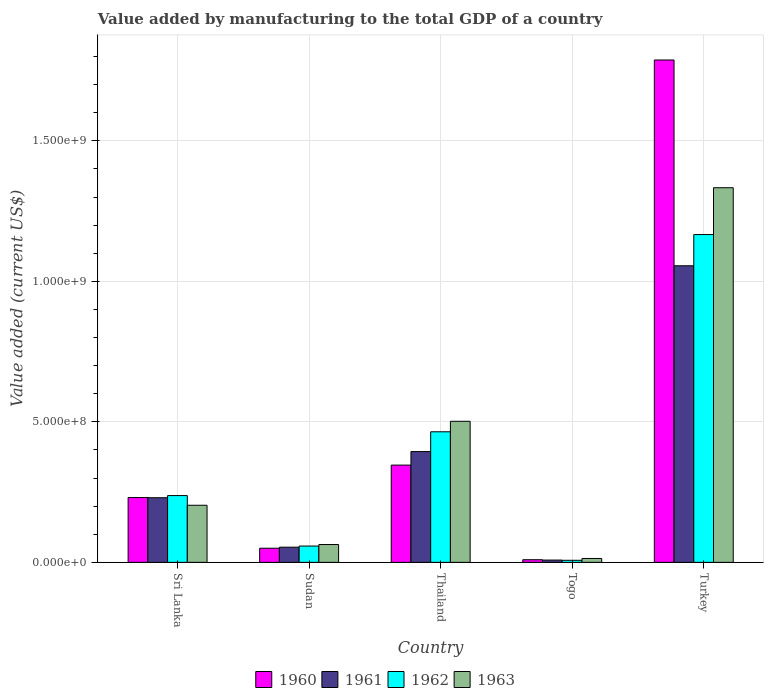How many different coloured bars are there?
Offer a very short reply. 4. How many bars are there on the 1st tick from the left?
Your answer should be compact. 4. How many bars are there on the 5th tick from the right?
Your answer should be compact. 4. What is the label of the 3rd group of bars from the left?
Your answer should be compact. Thailand. What is the value added by manufacturing to the total GDP in 1962 in Turkey?
Offer a terse response. 1.17e+09. Across all countries, what is the maximum value added by manufacturing to the total GDP in 1961?
Give a very brief answer. 1.06e+09. Across all countries, what is the minimum value added by manufacturing to the total GDP in 1961?
Keep it short and to the point. 8.15e+06. In which country was the value added by manufacturing to the total GDP in 1962 maximum?
Your response must be concise. Turkey. In which country was the value added by manufacturing to the total GDP in 1960 minimum?
Provide a short and direct response. Togo. What is the total value added by manufacturing to the total GDP in 1962 in the graph?
Offer a terse response. 1.93e+09. What is the difference between the value added by manufacturing to the total GDP in 1963 in Sri Lanka and that in Togo?
Make the answer very short. 1.89e+08. What is the difference between the value added by manufacturing to the total GDP in 1963 in Sudan and the value added by manufacturing to the total GDP in 1960 in Thailand?
Keep it short and to the point. -2.83e+08. What is the average value added by manufacturing to the total GDP in 1963 per country?
Give a very brief answer. 4.23e+08. What is the difference between the value added by manufacturing to the total GDP of/in 1962 and value added by manufacturing to the total GDP of/in 1963 in Togo?
Provide a short and direct response. -6.53e+06. In how many countries, is the value added by manufacturing to the total GDP in 1961 greater than 1500000000 US$?
Offer a terse response. 0. What is the ratio of the value added by manufacturing to the total GDP in 1961 in Togo to that in Turkey?
Give a very brief answer. 0.01. Is the value added by manufacturing to the total GDP in 1960 in Togo less than that in Turkey?
Make the answer very short. Yes. Is the difference between the value added by manufacturing to the total GDP in 1962 in Sudan and Thailand greater than the difference between the value added by manufacturing to the total GDP in 1963 in Sudan and Thailand?
Your answer should be compact. Yes. What is the difference between the highest and the second highest value added by manufacturing to the total GDP in 1960?
Make the answer very short. 1.56e+09. What is the difference between the highest and the lowest value added by manufacturing to the total GDP in 1961?
Provide a succinct answer. 1.05e+09. What does the 4th bar from the right in Thailand represents?
Your answer should be compact. 1960. How many bars are there?
Your answer should be compact. 20. Are all the bars in the graph horizontal?
Ensure brevity in your answer.  No. How many countries are there in the graph?
Make the answer very short. 5. What is the difference between two consecutive major ticks on the Y-axis?
Offer a terse response. 5.00e+08. Are the values on the major ticks of Y-axis written in scientific E-notation?
Offer a very short reply. Yes. Where does the legend appear in the graph?
Provide a short and direct response. Bottom center. How are the legend labels stacked?
Your response must be concise. Horizontal. What is the title of the graph?
Your answer should be compact. Value added by manufacturing to the total GDP of a country. Does "1996" appear as one of the legend labels in the graph?
Your answer should be very brief. No. What is the label or title of the Y-axis?
Ensure brevity in your answer.  Value added (current US$). What is the Value added (current US$) of 1960 in Sri Lanka?
Give a very brief answer. 2.31e+08. What is the Value added (current US$) in 1961 in Sri Lanka?
Your response must be concise. 2.30e+08. What is the Value added (current US$) in 1962 in Sri Lanka?
Give a very brief answer. 2.38e+08. What is the Value added (current US$) in 1963 in Sri Lanka?
Make the answer very short. 2.03e+08. What is the Value added (current US$) of 1960 in Sudan?
Give a very brief answer. 5.03e+07. What is the Value added (current US$) of 1961 in Sudan?
Provide a short and direct response. 5.40e+07. What is the Value added (current US$) in 1962 in Sudan?
Your response must be concise. 5.80e+07. What is the Value added (current US$) of 1963 in Sudan?
Make the answer very short. 6.35e+07. What is the Value added (current US$) in 1960 in Thailand?
Keep it short and to the point. 3.46e+08. What is the Value added (current US$) in 1961 in Thailand?
Provide a short and direct response. 3.94e+08. What is the Value added (current US$) of 1962 in Thailand?
Your response must be concise. 4.65e+08. What is the Value added (current US$) in 1963 in Thailand?
Offer a very short reply. 5.02e+08. What is the Value added (current US$) in 1960 in Togo?
Your answer should be compact. 9.38e+06. What is the Value added (current US$) in 1961 in Togo?
Your response must be concise. 8.15e+06. What is the Value added (current US$) in 1962 in Togo?
Provide a short and direct response. 7.35e+06. What is the Value added (current US$) in 1963 in Togo?
Provide a succinct answer. 1.39e+07. What is the Value added (current US$) of 1960 in Turkey?
Your answer should be very brief. 1.79e+09. What is the Value added (current US$) in 1961 in Turkey?
Keep it short and to the point. 1.06e+09. What is the Value added (current US$) of 1962 in Turkey?
Offer a very short reply. 1.17e+09. What is the Value added (current US$) of 1963 in Turkey?
Provide a short and direct response. 1.33e+09. Across all countries, what is the maximum Value added (current US$) of 1960?
Provide a succinct answer. 1.79e+09. Across all countries, what is the maximum Value added (current US$) of 1961?
Keep it short and to the point. 1.06e+09. Across all countries, what is the maximum Value added (current US$) of 1962?
Make the answer very short. 1.17e+09. Across all countries, what is the maximum Value added (current US$) of 1963?
Your answer should be compact. 1.33e+09. Across all countries, what is the minimum Value added (current US$) in 1960?
Ensure brevity in your answer.  9.38e+06. Across all countries, what is the minimum Value added (current US$) of 1961?
Make the answer very short. 8.15e+06. Across all countries, what is the minimum Value added (current US$) of 1962?
Offer a terse response. 7.35e+06. Across all countries, what is the minimum Value added (current US$) of 1963?
Give a very brief answer. 1.39e+07. What is the total Value added (current US$) of 1960 in the graph?
Provide a short and direct response. 2.42e+09. What is the total Value added (current US$) in 1961 in the graph?
Your answer should be compact. 1.74e+09. What is the total Value added (current US$) in 1962 in the graph?
Offer a terse response. 1.93e+09. What is the total Value added (current US$) in 1963 in the graph?
Make the answer very short. 2.12e+09. What is the difference between the Value added (current US$) in 1960 in Sri Lanka and that in Sudan?
Offer a terse response. 1.80e+08. What is the difference between the Value added (current US$) in 1961 in Sri Lanka and that in Sudan?
Offer a terse response. 1.76e+08. What is the difference between the Value added (current US$) of 1962 in Sri Lanka and that in Sudan?
Provide a succinct answer. 1.80e+08. What is the difference between the Value added (current US$) in 1963 in Sri Lanka and that in Sudan?
Keep it short and to the point. 1.40e+08. What is the difference between the Value added (current US$) of 1960 in Sri Lanka and that in Thailand?
Keep it short and to the point. -1.15e+08. What is the difference between the Value added (current US$) in 1961 in Sri Lanka and that in Thailand?
Offer a terse response. -1.64e+08. What is the difference between the Value added (current US$) of 1962 in Sri Lanka and that in Thailand?
Provide a short and direct response. -2.27e+08. What is the difference between the Value added (current US$) in 1963 in Sri Lanka and that in Thailand?
Ensure brevity in your answer.  -2.99e+08. What is the difference between the Value added (current US$) of 1960 in Sri Lanka and that in Togo?
Your response must be concise. 2.21e+08. What is the difference between the Value added (current US$) in 1961 in Sri Lanka and that in Togo?
Make the answer very short. 2.22e+08. What is the difference between the Value added (current US$) in 1962 in Sri Lanka and that in Togo?
Offer a very short reply. 2.30e+08. What is the difference between the Value added (current US$) of 1963 in Sri Lanka and that in Togo?
Ensure brevity in your answer.  1.89e+08. What is the difference between the Value added (current US$) of 1960 in Sri Lanka and that in Turkey?
Ensure brevity in your answer.  -1.56e+09. What is the difference between the Value added (current US$) of 1961 in Sri Lanka and that in Turkey?
Ensure brevity in your answer.  -8.26e+08. What is the difference between the Value added (current US$) of 1962 in Sri Lanka and that in Turkey?
Make the answer very short. -9.29e+08. What is the difference between the Value added (current US$) of 1963 in Sri Lanka and that in Turkey?
Offer a very short reply. -1.13e+09. What is the difference between the Value added (current US$) of 1960 in Sudan and that in Thailand?
Your answer should be very brief. -2.96e+08. What is the difference between the Value added (current US$) in 1961 in Sudan and that in Thailand?
Your response must be concise. -3.40e+08. What is the difference between the Value added (current US$) in 1962 in Sudan and that in Thailand?
Your answer should be compact. -4.07e+08. What is the difference between the Value added (current US$) of 1963 in Sudan and that in Thailand?
Offer a very short reply. -4.39e+08. What is the difference between the Value added (current US$) of 1960 in Sudan and that in Togo?
Ensure brevity in your answer.  4.09e+07. What is the difference between the Value added (current US$) of 1961 in Sudan and that in Togo?
Ensure brevity in your answer.  4.58e+07. What is the difference between the Value added (current US$) in 1962 in Sudan and that in Togo?
Offer a very short reply. 5.07e+07. What is the difference between the Value added (current US$) in 1963 in Sudan and that in Togo?
Offer a terse response. 4.96e+07. What is the difference between the Value added (current US$) in 1960 in Sudan and that in Turkey?
Provide a short and direct response. -1.74e+09. What is the difference between the Value added (current US$) in 1961 in Sudan and that in Turkey?
Offer a terse response. -1.00e+09. What is the difference between the Value added (current US$) of 1962 in Sudan and that in Turkey?
Provide a succinct answer. -1.11e+09. What is the difference between the Value added (current US$) in 1963 in Sudan and that in Turkey?
Give a very brief answer. -1.27e+09. What is the difference between the Value added (current US$) of 1960 in Thailand and that in Togo?
Provide a short and direct response. 3.37e+08. What is the difference between the Value added (current US$) of 1961 in Thailand and that in Togo?
Your answer should be very brief. 3.86e+08. What is the difference between the Value added (current US$) in 1962 in Thailand and that in Togo?
Your response must be concise. 4.57e+08. What is the difference between the Value added (current US$) of 1963 in Thailand and that in Togo?
Your response must be concise. 4.88e+08. What is the difference between the Value added (current US$) in 1960 in Thailand and that in Turkey?
Offer a very short reply. -1.44e+09. What is the difference between the Value added (current US$) of 1961 in Thailand and that in Turkey?
Give a very brief answer. -6.61e+08. What is the difference between the Value added (current US$) of 1962 in Thailand and that in Turkey?
Provide a short and direct response. -7.02e+08. What is the difference between the Value added (current US$) in 1963 in Thailand and that in Turkey?
Offer a very short reply. -8.31e+08. What is the difference between the Value added (current US$) of 1960 in Togo and that in Turkey?
Give a very brief answer. -1.78e+09. What is the difference between the Value added (current US$) of 1961 in Togo and that in Turkey?
Your answer should be very brief. -1.05e+09. What is the difference between the Value added (current US$) in 1962 in Togo and that in Turkey?
Ensure brevity in your answer.  -1.16e+09. What is the difference between the Value added (current US$) in 1963 in Togo and that in Turkey?
Keep it short and to the point. -1.32e+09. What is the difference between the Value added (current US$) of 1960 in Sri Lanka and the Value added (current US$) of 1961 in Sudan?
Ensure brevity in your answer.  1.77e+08. What is the difference between the Value added (current US$) in 1960 in Sri Lanka and the Value added (current US$) in 1962 in Sudan?
Provide a short and direct response. 1.73e+08. What is the difference between the Value added (current US$) of 1960 in Sri Lanka and the Value added (current US$) of 1963 in Sudan?
Offer a very short reply. 1.67e+08. What is the difference between the Value added (current US$) of 1961 in Sri Lanka and the Value added (current US$) of 1962 in Sudan?
Ensure brevity in your answer.  1.72e+08. What is the difference between the Value added (current US$) in 1961 in Sri Lanka and the Value added (current US$) in 1963 in Sudan?
Your response must be concise. 1.67e+08. What is the difference between the Value added (current US$) in 1962 in Sri Lanka and the Value added (current US$) in 1963 in Sudan?
Ensure brevity in your answer.  1.74e+08. What is the difference between the Value added (current US$) of 1960 in Sri Lanka and the Value added (current US$) of 1961 in Thailand?
Your answer should be very brief. -1.64e+08. What is the difference between the Value added (current US$) in 1960 in Sri Lanka and the Value added (current US$) in 1962 in Thailand?
Make the answer very short. -2.34e+08. What is the difference between the Value added (current US$) in 1960 in Sri Lanka and the Value added (current US$) in 1963 in Thailand?
Ensure brevity in your answer.  -2.71e+08. What is the difference between the Value added (current US$) of 1961 in Sri Lanka and the Value added (current US$) of 1962 in Thailand?
Provide a succinct answer. -2.35e+08. What is the difference between the Value added (current US$) of 1961 in Sri Lanka and the Value added (current US$) of 1963 in Thailand?
Your response must be concise. -2.72e+08. What is the difference between the Value added (current US$) in 1962 in Sri Lanka and the Value added (current US$) in 1963 in Thailand?
Your response must be concise. -2.64e+08. What is the difference between the Value added (current US$) of 1960 in Sri Lanka and the Value added (current US$) of 1961 in Togo?
Your answer should be very brief. 2.23e+08. What is the difference between the Value added (current US$) of 1960 in Sri Lanka and the Value added (current US$) of 1962 in Togo?
Offer a very short reply. 2.23e+08. What is the difference between the Value added (current US$) in 1960 in Sri Lanka and the Value added (current US$) in 1963 in Togo?
Your response must be concise. 2.17e+08. What is the difference between the Value added (current US$) in 1961 in Sri Lanka and the Value added (current US$) in 1962 in Togo?
Give a very brief answer. 2.23e+08. What is the difference between the Value added (current US$) of 1961 in Sri Lanka and the Value added (current US$) of 1963 in Togo?
Your answer should be compact. 2.16e+08. What is the difference between the Value added (current US$) of 1962 in Sri Lanka and the Value added (current US$) of 1963 in Togo?
Make the answer very short. 2.24e+08. What is the difference between the Value added (current US$) in 1960 in Sri Lanka and the Value added (current US$) in 1961 in Turkey?
Your answer should be compact. -8.25e+08. What is the difference between the Value added (current US$) in 1960 in Sri Lanka and the Value added (current US$) in 1962 in Turkey?
Give a very brief answer. -9.36e+08. What is the difference between the Value added (current US$) of 1960 in Sri Lanka and the Value added (current US$) of 1963 in Turkey?
Your answer should be compact. -1.10e+09. What is the difference between the Value added (current US$) in 1961 in Sri Lanka and the Value added (current US$) in 1962 in Turkey?
Offer a very short reply. -9.37e+08. What is the difference between the Value added (current US$) of 1961 in Sri Lanka and the Value added (current US$) of 1963 in Turkey?
Your answer should be very brief. -1.10e+09. What is the difference between the Value added (current US$) of 1962 in Sri Lanka and the Value added (current US$) of 1963 in Turkey?
Your answer should be very brief. -1.10e+09. What is the difference between the Value added (current US$) in 1960 in Sudan and the Value added (current US$) in 1961 in Thailand?
Your answer should be very brief. -3.44e+08. What is the difference between the Value added (current US$) in 1960 in Sudan and the Value added (current US$) in 1962 in Thailand?
Keep it short and to the point. -4.14e+08. What is the difference between the Value added (current US$) of 1960 in Sudan and the Value added (current US$) of 1963 in Thailand?
Offer a very short reply. -4.52e+08. What is the difference between the Value added (current US$) of 1961 in Sudan and the Value added (current US$) of 1962 in Thailand?
Keep it short and to the point. -4.11e+08. What is the difference between the Value added (current US$) of 1961 in Sudan and the Value added (current US$) of 1963 in Thailand?
Your response must be concise. -4.48e+08. What is the difference between the Value added (current US$) of 1962 in Sudan and the Value added (current US$) of 1963 in Thailand?
Make the answer very short. -4.44e+08. What is the difference between the Value added (current US$) of 1960 in Sudan and the Value added (current US$) of 1961 in Togo?
Ensure brevity in your answer.  4.21e+07. What is the difference between the Value added (current US$) of 1960 in Sudan and the Value added (current US$) of 1962 in Togo?
Ensure brevity in your answer.  4.29e+07. What is the difference between the Value added (current US$) of 1960 in Sudan and the Value added (current US$) of 1963 in Togo?
Your answer should be compact. 3.64e+07. What is the difference between the Value added (current US$) in 1961 in Sudan and the Value added (current US$) in 1962 in Togo?
Provide a short and direct response. 4.66e+07. What is the difference between the Value added (current US$) in 1961 in Sudan and the Value added (current US$) in 1963 in Togo?
Your response must be concise. 4.01e+07. What is the difference between the Value added (current US$) of 1962 in Sudan and the Value added (current US$) of 1963 in Togo?
Offer a very short reply. 4.41e+07. What is the difference between the Value added (current US$) of 1960 in Sudan and the Value added (current US$) of 1961 in Turkey?
Provide a short and direct response. -1.01e+09. What is the difference between the Value added (current US$) in 1960 in Sudan and the Value added (current US$) in 1962 in Turkey?
Provide a succinct answer. -1.12e+09. What is the difference between the Value added (current US$) of 1960 in Sudan and the Value added (current US$) of 1963 in Turkey?
Ensure brevity in your answer.  -1.28e+09. What is the difference between the Value added (current US$) in 1961 in Sudan and the Value added (current US$) in 1962 in Turkey?
Make the answer very short. -1.11e+09. What is the difference between the Value added (current US$) in 1961 in Sudan and the Value added (current US$) in 1963 in Turkey?
Provide a short and direct response. -1.28e+09. What is the difference between the Value added (current US$) in 1962 in Sudan and the Value added (current US$) in 1963 in Turkey?
Make the answer very short. -1.28e+09. What is the difference between the Value added (current US$) in 1960 in Thailand and the Value added (current US$) in 1961 in Togo?
Offer a very short reply. 3.38e+08. What is the difference between the Value added (current US$) in 1960 in Thailand and the Value added (current US$) in 1962 in Togo?
Offer a terse response. 3.39e+08. What is the difference between the Value added (current US$) of 1960 in Thailand and the Value added (current US$) of 1963 in Togo?
Offer a terse response. 3.32e+08. What is the difference between the Value added (current US$) of 1961 in Thailand and the Value added (current US$) of 1962 in Togo?
Offer a very short reply. 3.87e+08. What is the difference between the Value added (current US$) of 1961 in Thailand and the Value added (current US$) of 1963 in Togo?
Ensure brevity in your answer.  3.80e+08. What is the difference between the Value added (current US$) in 1962 in Thailand and the Value added (current US$) in 1963 in Togo?
Your answer should be very brief. 4.51e+08. What is the difference between the Value added (current US$) in 1960 in Thailand and the Value added (current US$) in 1961 in Turkey?
Keep it short and to the point. -7.09e+08. What is the difference between the Value added (current US$) in 1960 in Thailand and the Value added (current US$) in 1962 in Turkey?
Keep it short and to the point. -8.21e+08. What is the difference between the Value added (current US$) of 1960 in Thailand and the Value added (current US$) of 1963 in Turkey?
Your answer should be very brief. -9.87e+08. What is the difference between the Value added (current US$) of 1961 in Thailand and the Value added (current US$) of 1962 in Turkey?
Your answer should be compact. -7.72e+08. What is the difference between the Value added (current US$) in 1961 in Thailand and the Value added (current US$) in 1963 in Turkey?
Give a very brief answer. -9.39e+08. What is the difference between the Value added (current US$) in 1962 in Thailand and the Value added (current US$) in 1963 in Turkey?
Provide a short and direct response. -8.69e+08. What is the difference between the Value added (current US$) of 1960 in Togo and the Value added (current US$) of 1961 in Turkey?
Your response must be concise. -1.05e+09. What is the difference between the Value added (current US$) in 1960 in Togo and the Value added (current US$) in 1962 in Turkey?
Your answer should be compact. -1.16e+09. What is the difference between the Value added (current US$) of 1960 in Togo and the Value added (current US$) of 1963 in Turkey?
Offer a very short reply. -1.32e+09. What is the difference between the Value added (current US$) in 1961 in Togo and the Value added (current US$) in 1962 in Turkey?
Your answer should be compact. -1.16e+09. What is the difference between the Value added (current US$) of 1961 in Togo and the Value added (current US$) of 1963 in Turkey?
Give a very brief answer. -1.33e+09. What is the difference between the Value added (current US$) of 1962 in Togo and the Value added (current US$) of 1963 in Turkey?
Ensure brevity in your answer.  -1.33e+09. What is the average Value added (current US$) of 1960 per country?
Make the answer very short. 4.85e+08. What is the average Value added (current US$) in 1961 per country?
Your answer should be very brief. 3.48e+08. What is the average Value added (current US$) of 1962 per country?
Make the answer very short. 3.87e+08. What is the average Value added (current US$) in 1963 per country?
Offer a very short reply. 4.23e+08. What is the difference between the Value added (current US$) in 1960 and Value added (current US$) in 1961 in Sri Lanka?
Offer a very short reply. 6.30e+05. What is the difference between the Value added (current US$) in 1960 and Value added (current US$) in 1962 in Sri Lanka?
Provide a succinct answer. -6.98e+06. What is the difference between the Value added (current US$) of 1960 and Value added (current US$) of 1963 in Sri Lanka?
Provide a succinct answer. 2.75e+07. What is the difference between the Value added (current US$) of 1961 and Value added (current US$) of 1962 in Sri Lanka?
Provide a short and direct response. -7.61e+06. What is the difference between the Value added (current US$) in 1961 and Value added (current US$) in 1963 in Sri Lanka?
Your response must be concise. 2.68e+07. What is the difference between the Value added (current US$) in 1962 and Value added (current US$) in 1963 in Sri Lanka?
Keep it short and to the point. 3.45e+07. What is the difference between the Value added (current US$) in 1960 and Value added (current US$) in 1961 in Sudan?
Provide a succinct answer. -3.73e+06. What is the difference between the Value added (current US$) of 1960 and Value added (current US$) of 1962 in Sudan?
Offer a terse response. -7.75e+06. What is the difference between the Value added (current US$) in 1960 and Value added (current US$) in 1963 in Sudan?
Ensure brevity in your answer.  -1.32e+07. What is the difference between the Value added (current US$) of 1961 and Value added (current US$) of 1962 in Sudan?
Keep it short and to the point. -4.02e+06. What is the difference between the Value added (current US$) in 1961 and Value added (current US$) in 1963 in Sudan?
Ensure brevity in your answer.  -9.48e+06. What is the difference between the Value added (current US$) in 1962 and Value added (current US$) in 1963 in Sudan?
Provide a short and direct response. -5.46e+06. What is the difference between the Value added (current US$) of 1960 and Value added (current US$) of 1961 in Thailand?
Provide a succinct answer. -4.81e+07. What is the difference between the Value added (current US$) of 1960 and Value added (current US$) of 1962 in Thailand?
Your answer should be compact. -1.19e+08. What is the difference between the Value added (current US$) in 1960 and Value added (current US$) in 1963 in Thailand?
Your answer should be compact. -1.56e+08. What is the difference between the Value added (current US$) of 1961 and Value added (current US$) of 1962 in Thailand?
Your answer should be very brief. -7.05e+07. What is the difference between the Value added (current US$) in 1961 and Value added (current US$) in 1963 in Thailand?
Ensure brevity in your answer.  -1.08e+08. What is the difference between the Value added (current US$) in 1962 and Value added (current US$) in 1963 in Thailand?
Offer a terse response. -3.73e+07. What is the difference between the Value added (current US$) in 1960 and Value added (current US$) in 1961 in Togo?
Offer a very short reply. 1.23e+06. What is the difference between the Value added (current US$) of 1960 and Value added (current US$) of 1962 in Togo?
Provide a succinct answer. 2.03e+06. What is the difference between the Value added (current US$) in 1960 and Value added (current US$) in 1963 in Togo?
Your answer should be compact. -4.50e+06. What is the difference between the Value added (current US$) in 1961 and Value added (current US$) in 1962 in Togo?
Give a very brief answer. 8.08e+05. What is the difference between the Value added (current US$) in 1961 and Value added (current US$) in 1963 in Togo?
Provide a succinct answer. -5.72e+06. What is the difference between the Value added (current US$) of 1962 and Value added (current US$) of 1963 in Togo?
Your response must be concise. -6.53e+06. What is the difference between the Value added (current US$) in 1960 and Value added (current US$) in 1961 in Turkey?
Give a very brief answer. 7.32e+08. What is the difference between the Value added (current US$) in 1960 and Value added (current US$) in 1962 in Turkey?
Your answer should be compact. 6.21e+08. What is the difference between the Value added (current US$) of 1960 and Value added (current US$) of 1963 in Turkey?
Your answer should be very brief. 4.55e+08. What is the difference between the Value added (current US$) in 1961 and Value added (current US$) in 1962 in Turkey?
Keep it short and to the point. -1.11e+08. What is the difference between the Value added (current US$) in 1961 and Value added (current US$) in 1963 in Turkey?
Your response must be concise. -2.78e+08. What is the difference between the Value added (current US$) of 1962 and Value added (current US$) of 1963 in Turkey?
Provide a succinct answer. -1.67e+08. What is the ratio of the Value added (current US$) of 1960 in Sri Lanka to that in Sudan?
Give a very brief answer. 4.59. What is the ratio of the Value added (current US$) of 1961 in Sri Lanka to that in Sudan?
Offer a terse response. 4.26. What is the ratio of the Value added (current US$) in 1962 in Sri Lanka to that in Sudan?
Offer a terse response. 4.1. What is the ratio of the Value added (current US$) of 1963 in Sri Lanka to that in Sudan?
Provide a short and direct response. 3.2. What is the ratio of the Value added (current US$) in 1960 in Sri Lanka to that in Thailand?
Make the answer very short. 0.67. What is the ratio of the Value added (current US$) in 1961 in Sri Lanka to that in Thailand?
Your answer should be compact. 0.58. What is the ratio of the Value added (current US$) of 1962 in Sri Lanka to that in Thailand?
Ensure brevity in your answer.  0.51. What is the ratio of the Value added (current US$) in 1963 in Sri Lanka to that in Thailand?
Give a very brief answer. 0.4. What is the ratio of the Value added (current US$) in 1960 in Sri Lanka to that in Togo?
Your answer should be compact. 24.59. What is the ratio of the Value added (current US$) in 1961 in Sri Lanka to that in Togo?
Your response must be concise. 28.21. What is the ratio of the Value added (current US$) of 1962 in Sri Lanka to that in Togo?
Offer a very short reply. 32.35. What is the ratio of the Value added (current US$) in 1963 in Sri Lanka to that in Togo?
Ensure brevity in your answer.  14.64. What is the ratio of the Value added (current US$) of 1960 in Sri Lanka to that in Turkey?
Keep it short and to the point. 0.13. What is the ratio of the Value added (current US$) of 1961 in Sri Lanka to that in Turkey?
Your response must be concise. 0.22. What is the ratio of the Value added (current US$) in 1962 in Sri Lanka to that in Turkey?
Keep it short and to the point. 0.2. What is the ratio of the Value added (current US$) of 1963 in Sri Lanka to that in Turkey?
Your response must be concise. 0.15. What is the ratio of the Value added (current US$) in 1960 in Sudan to that in Thailand?
Offer a terse response. 0.15. What is the ratio of the Value added (current US$) in 1961 in Sudan to that in Thailand?
Ensure brevity in your answer.  0.14. What is the ratio of the Value added (current US$) in 1962 in Sudan to that in Thailand?
Offer a very short reply. 0.12. What is the ratio of the Value added (current US$) of 1963 in Sudan to that in Thailand?
Provide a succinct answer. 0.13. What is the ratio of the Value added (current US$) in 1960 in Sudan to that in Togo?
Keep it short and to the point. 5.36. What is the ratio of the Value added (current US$) in 1961 in Sudan to that in Togo?
Provide a succinct answer. 6.62. What is the ratio of the Value added (current US$) of 1962 in Sudan to that in Togo?
Provide a succinct answer. 7.9. What is the ratio of the Value added (current US$) in 1963 in Sudan to that in Togo?
Your answer should be very brief. 4.57. What is the ratio of the Value added (current US$) of 1960 in Sudan to that in Turkey?
Your answer should be very brief. 0.03. What is the ratio of the Value added (current US$) in 1961 in Sudan to that in Turkey?
Give a very brief answer. 0.05. What is the ratio of the Value added (current US$) in 1962 in Sudan to that in Turkey?
Offer a terse response. 0.05. What is the ratio of the Value added (current US$) of 1963 in Sudan to that in Turkey?
Ensure brevity in your answer.  0.05. What is the ratio of the Value added (current US$) of 1960 in Thailand to that in Togo?
Your answer should be compact. 36.9. What is the ratio of the Value added (current US$) in 1961 in Thailand to that in Togo?
Your response must be concise. 48.34. What is the ratio of the Value added (current US$) in 1962 in Thailand to that in Togo?
Offer a terse response. 63.26. What is the ratio of the Value added (current US$) in 1963 in Thailand to that in Togo?
Ensure brevity in your answer.  36.18. What is the ratio of the Value added (current US$) of 1960 in Thailand to that in Turkey?
Offer a terse response. 0.19. What is the ratio of the Value added (current US$) in 1961 in Thailand to that in Turkey?
Provide a succinct answer. 0.37. What is the ratio of the Value added (current US$) of 1962 in Thailand to that in Turkey?
Ensure brevity in your answer.  0.4. What is the ratio of the Value added (current US$) in 1963 in Thailand to that in Turkey?
Provide a short and direct response. 0.38. What is the ratio of the Value added (current US$) in 1960 in Togo to that in Turkey?
Ensure brevity in your answer.  0.01. What is the ratio of the Value added (current US$) of 1961 in Togo to that in Turkey?
Give a very brief answer. 0.01. What is the ratio of the Value added (current US$) of 1962 in Togo to that in Turkey?
Provide a short and direct response. 0.01. What is the ratio of the Value added (current US$) in 1963 in Togo to that in Turkey?
Make the answer very short. 0.01. What is the difference between the highest and the second highest Value added (current US$) of 1960?
Make the answer very short. 1.44e+09. What is the difference between the highest and the second highest Value added (current US$) in 1961?
Make the answer very short. 6.61e+08. What is the difference between the highest and the second highest Value added (current US$) of 1962?
Offer a very short reply. 7.02e+08. What is the difference between the highest and the second highest Value added (current US$) of 1963?
Your answer should be very brief. 8.31e+08. What is the difference between the highest and the lowest Value added (current US$) of 1960?
Provide a short and direct response. 1.78e+09. What is the difference between the highest and the lowest Value added (current US$) in 1961?
Offer a very short reply. 1.05e+09. What is the difference between the highest and the lowest Value added (current US$) in 1962?
Your answer should be very brief. 1.16e+09. What is the difference between the highest and the lowest Value added (current US$) in 1963?
Offer a very short reply. 1.32e+09. 